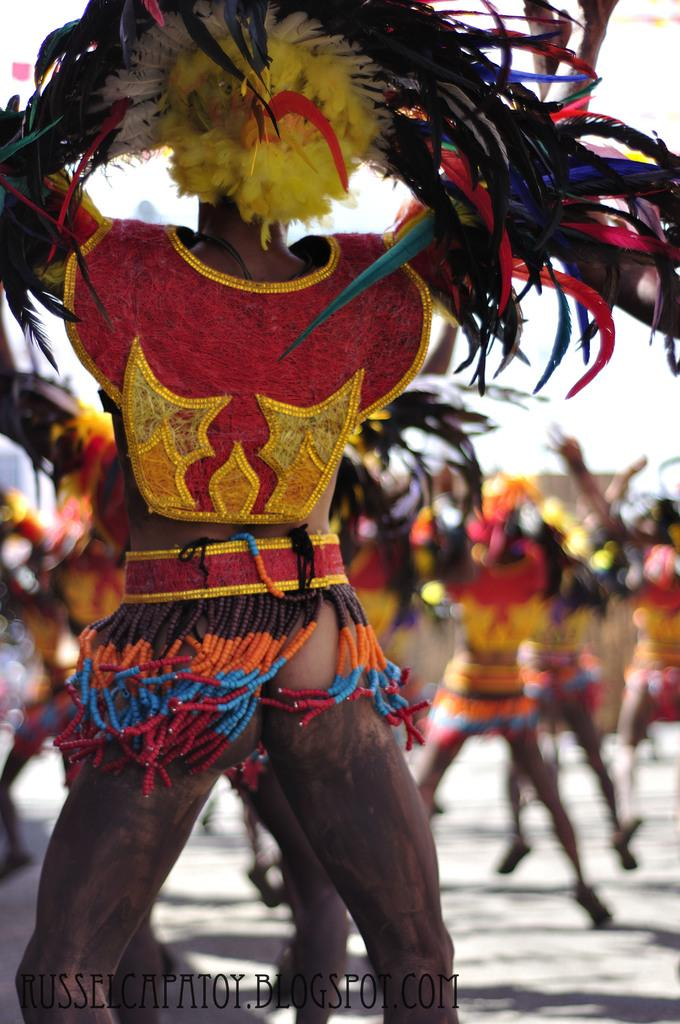How many people are in the image? There are persons in the image. What are the persons wearing in the image? The persons are wearing traditional dress. What event might the traditional dress be associated with? The traditional dress is for a carnival fest. Can you tell me how many wheels are visible in the image? There are no wheels present in the image; it features persons wearing traditional dress for a carnival fest. What type of kettle can be seen in the image? There is no kettle present in the image. 